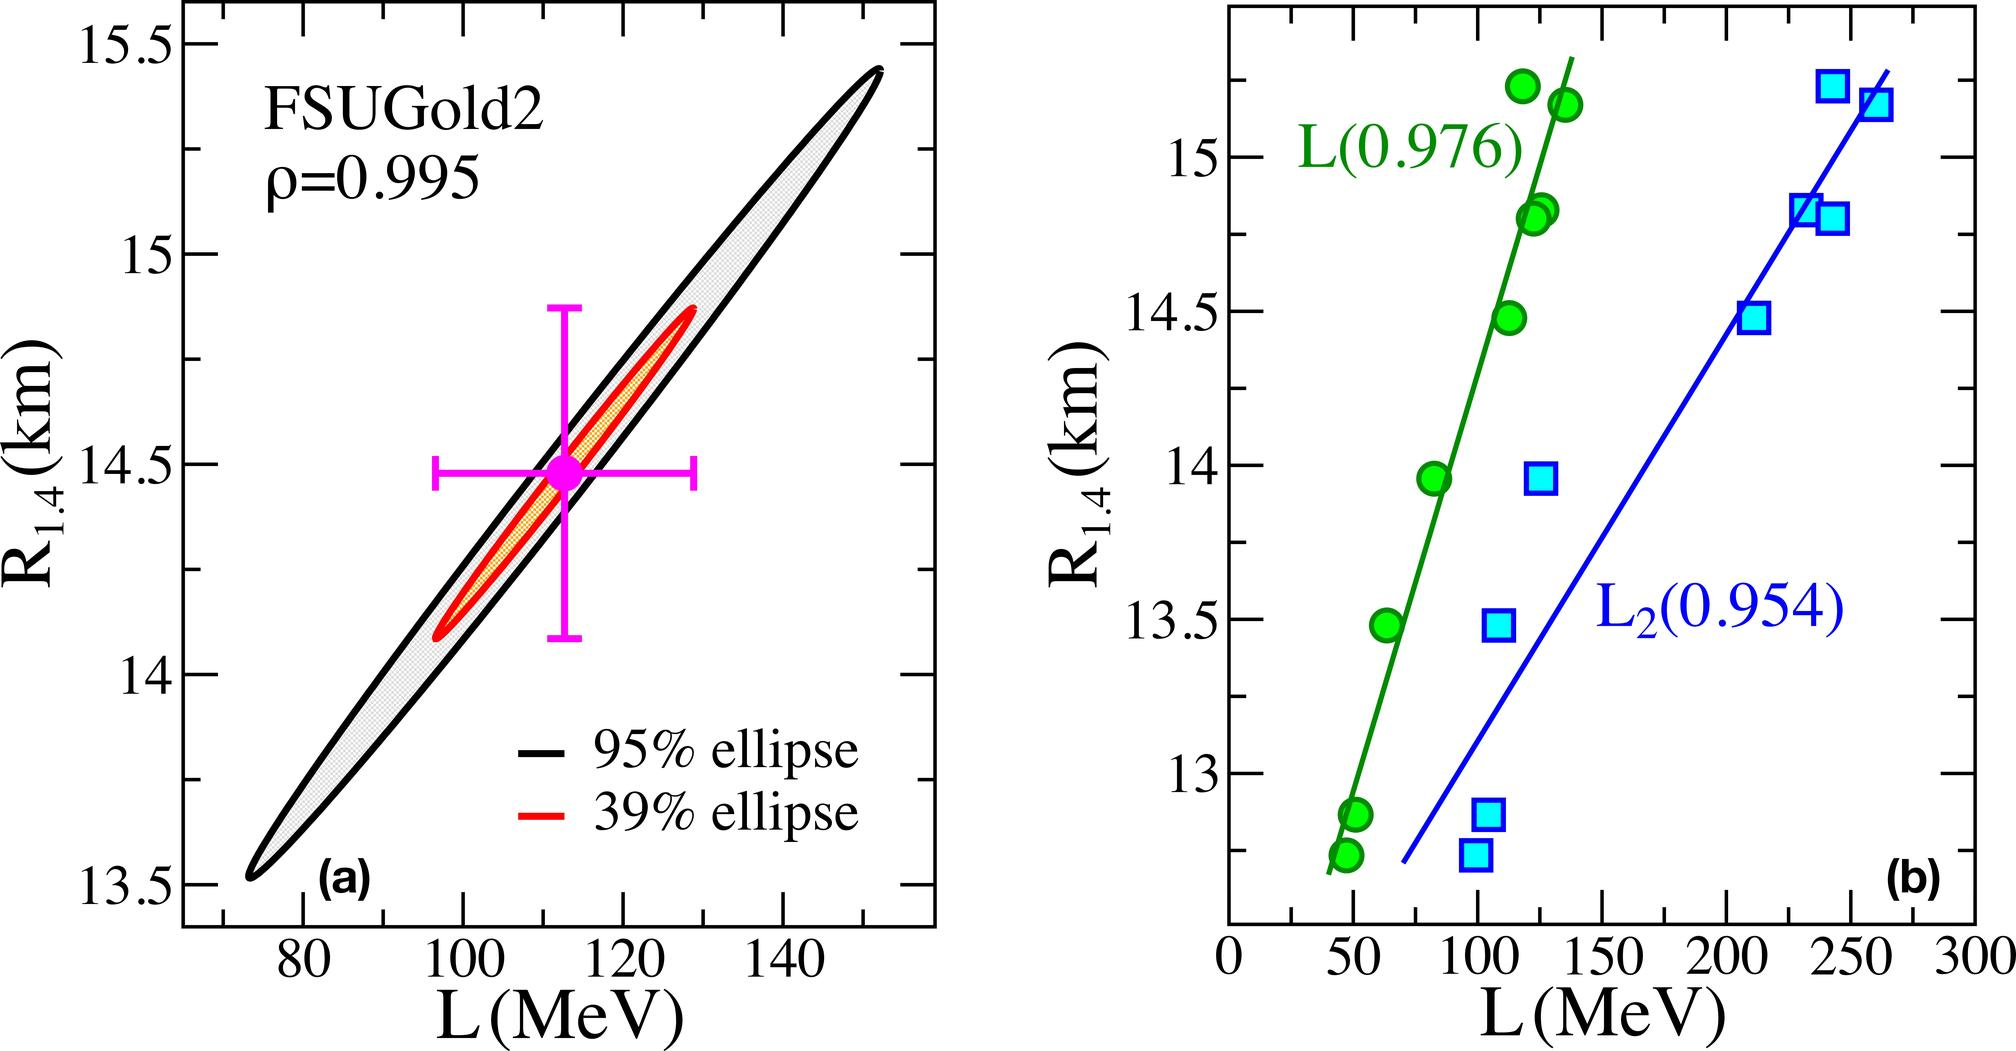What is the correlation coefficient (ρ) for the FSUGold2 equation of state (EoS) as shown in the figure (a)? A. ρ=0.995 B. ρ=0.976 C. ρ=0.954 D. ρ=0.850 The correlation coefficient for the FSUGold2 equation of state as shown in figure (a) is ρ=0.995. This value indicates a very high degree of correlation, reflecting strong predictive accuracy of the FSUGold2 model in this context. The correct answer to your query, therefore, is Option A: ρ=0.995. Understanding these coefficients helps in evaluating how well the model predicts real-world data, which is crucial for theoretical and practical applications in physics. 